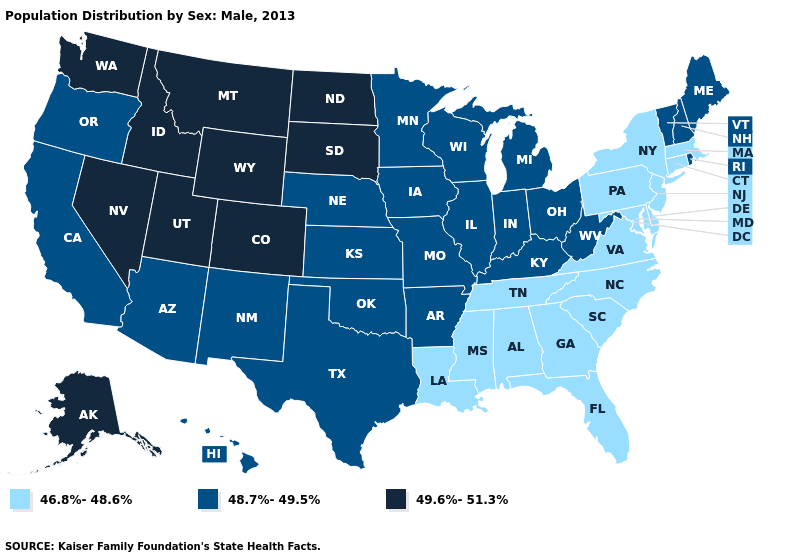Does the map have missing data?
Concise answer only. No. Does New Mexico have the lowest value in the West?
Concise answer only. Yes. What is the lowest value in states that border Michigan?
Concise answer only. 48.7%-49.5%. Name the states that have a value in the range 46.8%-48.6%?
Short answer required. Alabama, Connecticut, Delaware, Florida, Georgia, Louisiana, Maryland, Massachusetts, Mississippi, New Jersey, New York, North Carolina, Pennsylvania, South Carolina, Tennessee, Virginia. What is the value of Maryland?
Be succinct. 46.8%-48.6%. Which states hav the highest value in the Northeast?
Be succinct. Maine, New Hampshire, Rhode Island, Vermont. What is the value of Rhode Island?
Keep it brief. 48.7%-49.5%. Name the states that have a value in the range 46.8%-48.6%?
Write a very short answer. Alabama, Connecticut, Delaware, Florida, Georgia, Louisiana, Maryland, Massachusetts, Mississippi, New Jersey, New York, North Carolina, Pennsylvania, South Carolina, Tennessee, Virginia. Does Kansas have the lowest value in the USA?
Write a very short answer. No. Which states have the lowest value in the USA?
Keep it brief. Alabama, Connecticut, Delaware, Florida, Georgia, Louisiana, Maryland, Massachusetts, Mississippi, New Jersey, New York, North Carolina, Pennsylvania, South Carolina, Tennessee, Virginia. Does the first symbol in the legend represent the smallest category?
Answer briefly. Yes. How many symbols are there in the legend?
Be succinct. 3. Name the states that have a value in the range 48.7%-49.5%?
Short answer required. Arizona, Arkansas, California, Hawaii, Illinois, Indiana, Iowa, Kansas, Kentucky, Maine, Michigan, Minnesota, Missouri, Nebraska, New Hampshire, New Mexico, Ohio, Oklahoma, Oregon, Rhode Island, Texas, Vermont, West Virginia, Wisconsin. What is the lowest value in the West?
Short answer required. 48.7%-49.5%. Which states have the highest value in the USA?
Write a very short answer. Alaska, Colorado, Idaho, Montana, Nevada, North Dakota, South Dakota, Utah, Washington, Wyoming. 